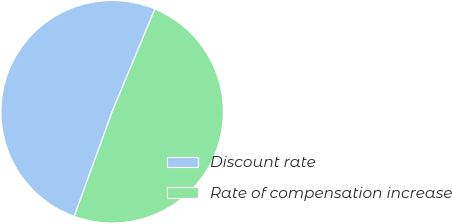Convert chart. <chart><loc_0><loc_0><loc_500><loc_500><pie_chart><fcel>Discount rate<fcel>Rate of compensation increase<nl><fcel>50.74%<fcel>49.26%<nl></chart> 